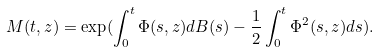Convert formula to latex. <formula><loc_0><loc_0><loc_500><loc_500>M ( t , z ) = \exp ( \int _ { 0 } ^ { t } \Phi ( s , z ) d B ( s ) - \frac { 1 } { 2 } \int _ { 0 } ^ { t } \Phi ^ { 2 } ( s , z ) d s ) .</formula> 